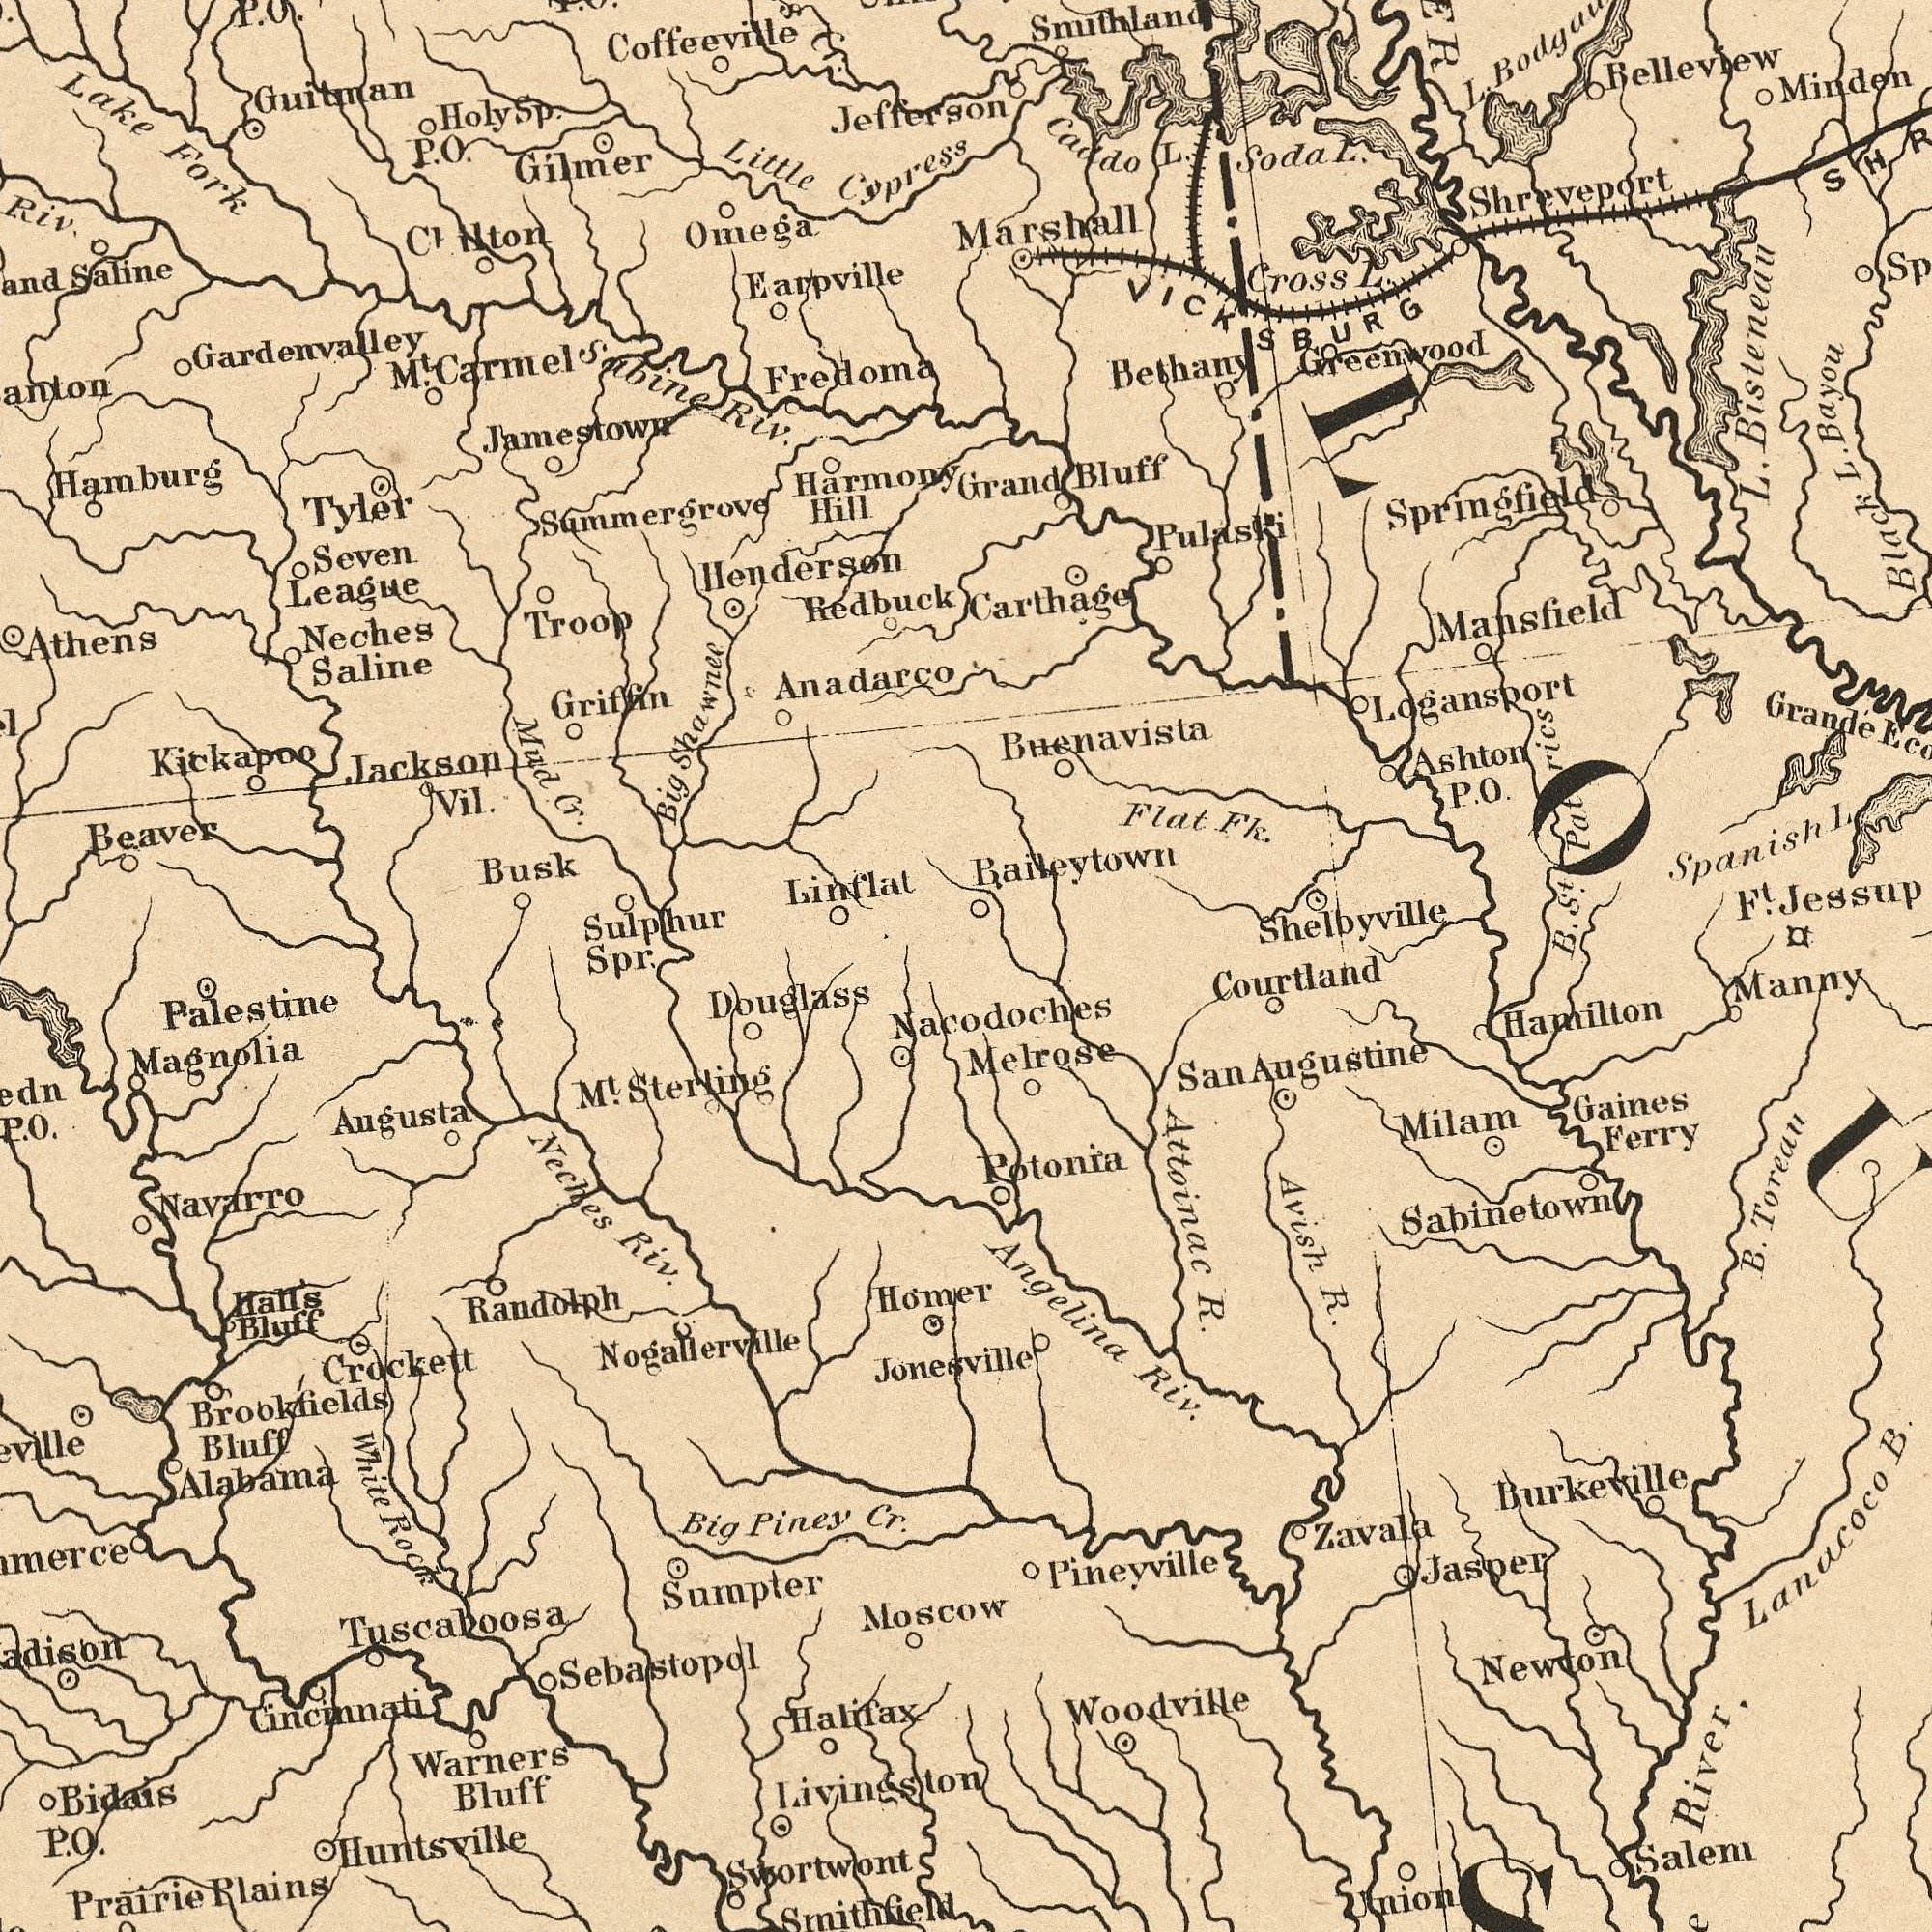What text is visible in the upper-left corner? Sulphur Spr. Anadarco Guitman Beaver Busk Hamburg Harmony Hill Neches Saline Redbuck Little Cypress Jackson Vil. Athens Jamestown Hendersen Seven League Riv. Mud Cr. Tyler Sabine Riv. Saline Big Shawnee Gilmer Fredoma Troop Sammergrove Griffin Earpville Cr. Clinton Omega Lake Fork Gardenvalley Jefferson Kickapoo Linflat M<sup>t</sup>. Carmel Coffeeville P. O. Holy Sp. P. O. What text can you see in the bottom-right section? Nacodoches B. Toreau Avish R. Angelina Riv. Attoinac R. Hamilton Woodville River Lanacoco B. Pineyville Melrose Newton Manny Potonia Sabinetown Gaines Ferry Courtland Jasper Zavala Burkeville Salem Milam Union San Augustine What text is visible in the lower-left corner? Warners Bluff Alabama Neches Riv. Prairie Plains Douglass Brookfields Bluff Cincinnati Halifax Big Piney Cr. Magnolia Huntsville Navarro Tuscaloosa Nogallerville Bidais P. O. Jonesville Swortwont Smithfield White Rock Palestine Halls Bluff Randolph M<sup>t</sup>. Sterling ##merce Moscow Crockett Augusta Hómer Sumpter Sebastopol O. Livingston What text appears in the top-right area of the image? Shelbyville Buenavista Carthage Belleview Smithland Minden L. Black L. Bayou Greenwood Caddo L. Grandé Cross L. Bethany Flat Fk. Mansfield Grand Bluff Marshall B. S<sup>t</sup>. Pat rics Logansport Springfield Ashton P. O. L. Bisteneau Spanish L Baileytown Soda L. Shreveport F<sup>t</sup>. Jessup VICKSBURG Pulaski 